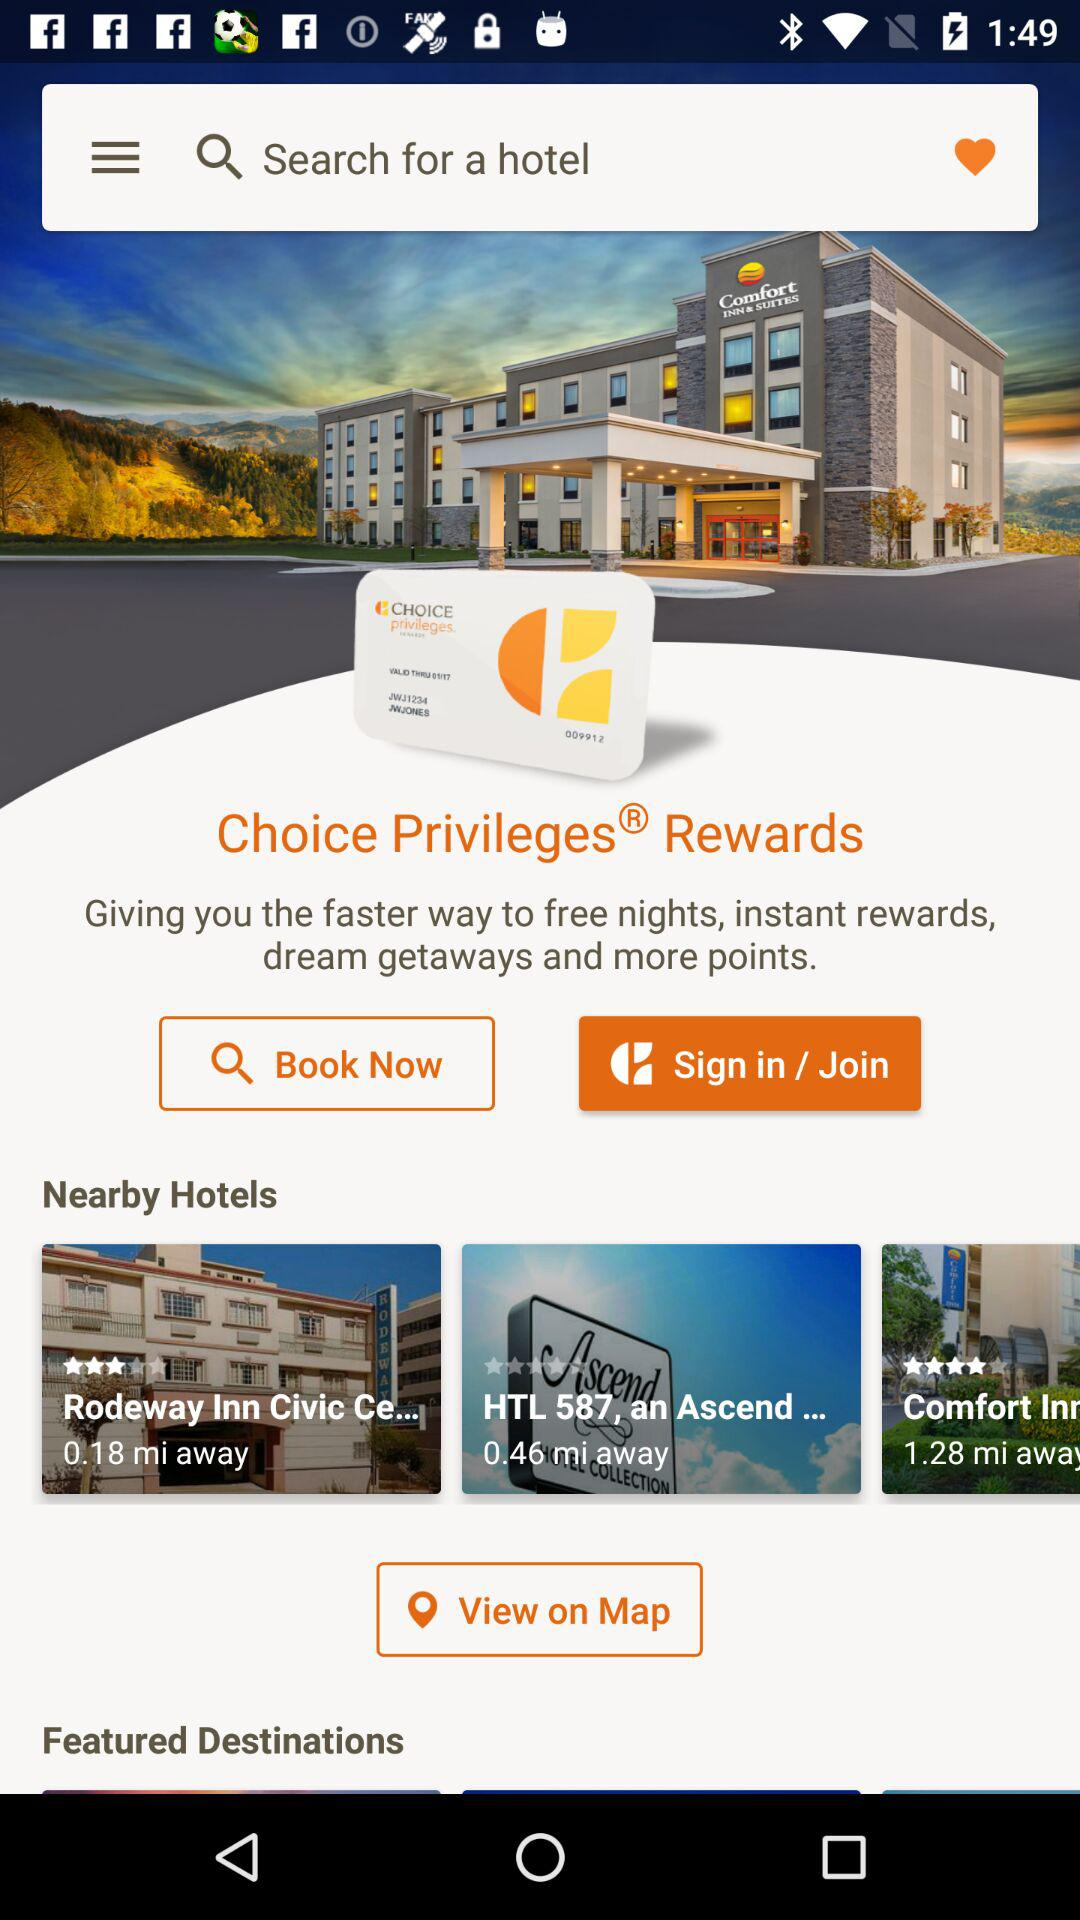What is the rating for the hotel "HTL 587, an Ascend..."? The rating is 0 stars. 